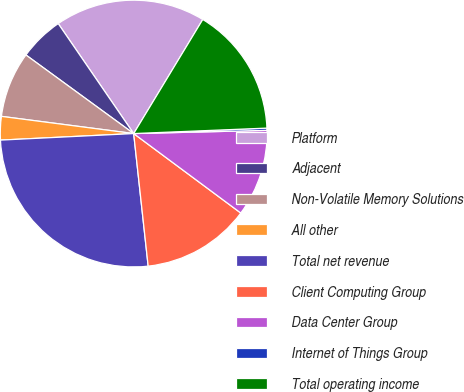Convert chart. <chart><loc_0><loc_0><loc_500><loc_500><pie_chart><fcel>Platform<fcel>Adjacent<fcel>Non-Volatile Memory Solutions<fcel>All other<fcel>Total net revenue<fcel>Client Computing Group<fcel>Data Center Group<fcel>Internet of Things Group<fcel>Total operating income<nl><fcel>18.24%<fcel>5.4%<fcel>7.97%<fcel>2.84%<fcel>25.95%<fcel>13.11%<fcel>10.54%<fcel>0.27%<fcel>15.68%<nl></chart> 